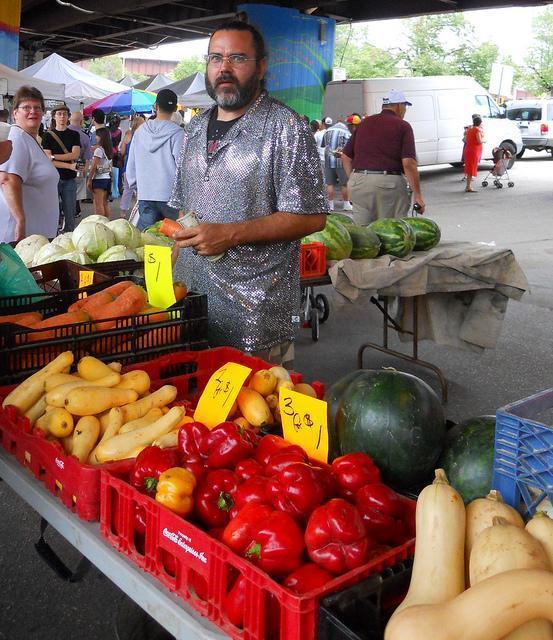How many people are in the photo?
Give a very brief answer. 6. How many giraffes are there?
Give a very brief answer. 0. 